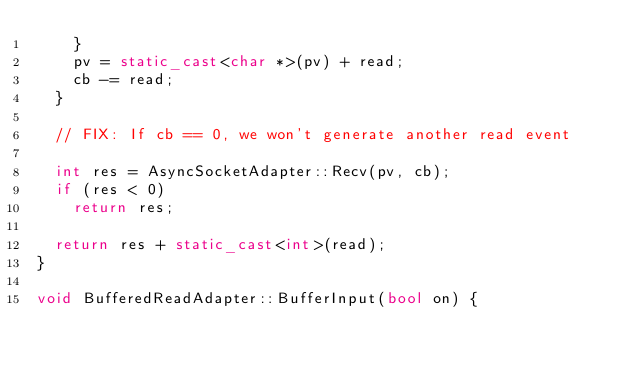Convert code to text. <code><loc_0><loc_0><loc_500><loc_500><_C++_>    }
    pv = static_cast<char *>(pv) + read;
    cb -= read;
  }

  // FIX: If cb == 0, we won't generate another read event

  int res = AsyncSocketAdapter::Recv(pv, cb);
  if (res < 0)
    return res;

  return res + static_cast<int>(read);
}

void BufferedReadAdapter::BufferInput(bool on) {</code> 